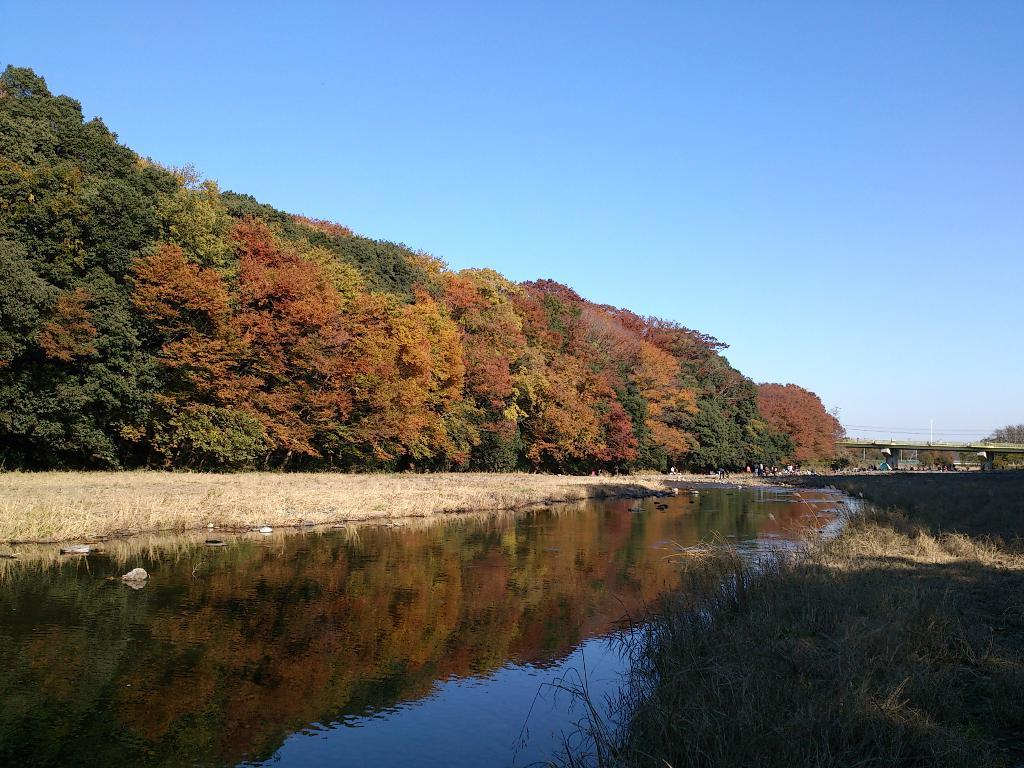What type of natural feature is present in the image? There is a river in the image. What is the condition of the vegetation near the river? There is dry grass beside the river. What type of vegetation is located behind the dry grass? There is a thicket behind the dry grass. What can be seen in the background of the image? There is a wall in the background of the image. What type of arch can be seen in the image? There is no arch present in the image. What beliefs are represented by the objects in the image? The image does not depict any objects that represent beliefs. 